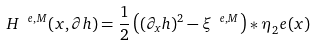<formula> <loc_0><loc_0><loc_500><loc_500>H ^ { \ e , M } ( x , \partial h ) = \frac { 1 } { 2 } \left ( ( \partial _ { x } h ) ^ { 2 } - \xi ^ { \ e , M } \right ) * \eta _ { 2 } ^ { \ } e ( x )</formula> 